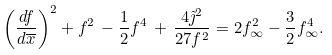Convert formula to latex. <formula><loc_0><loc_0><loc_500><loc_500>\left ( \frac { d f } { d \overline { x } } \right ) ^ { 2 } + f ^ { 2 } \, - \frac { 1 } { 2 } f ^ { 4 } \, + \, \frac { 4 \tilde { \jmath } ^ { 2 } } { 2 7 f ^ { 2 } } = 2 f _ { \infty } ^ { 2 } - \frac { 3 } { 2 } f _ { \infty } ^ { 4 } .</formula> 